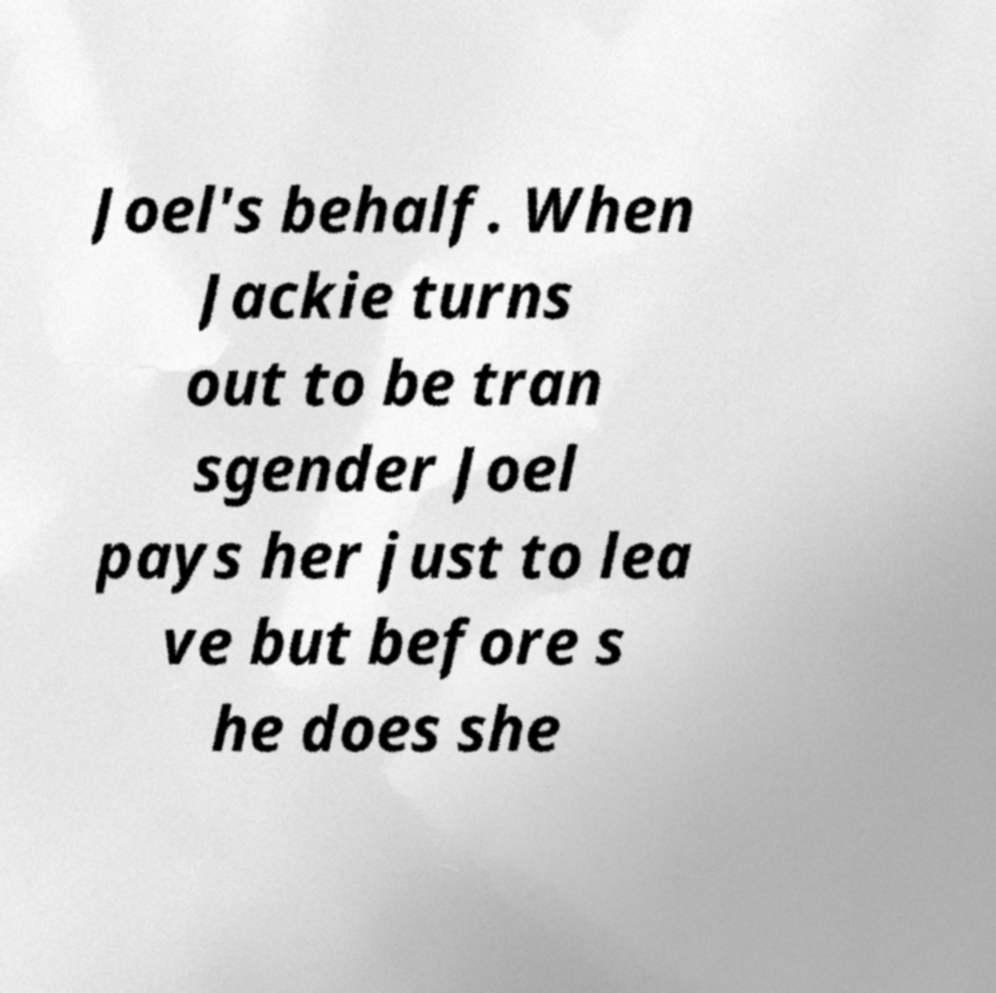Can you read and provide the text displayed in the image?This photo seems to have some interesting text. Can you extract and type it out for me? Joel's behalf. When Jackie turns out to be tran sgender Joel pays her just to lea ve but before s he does she 